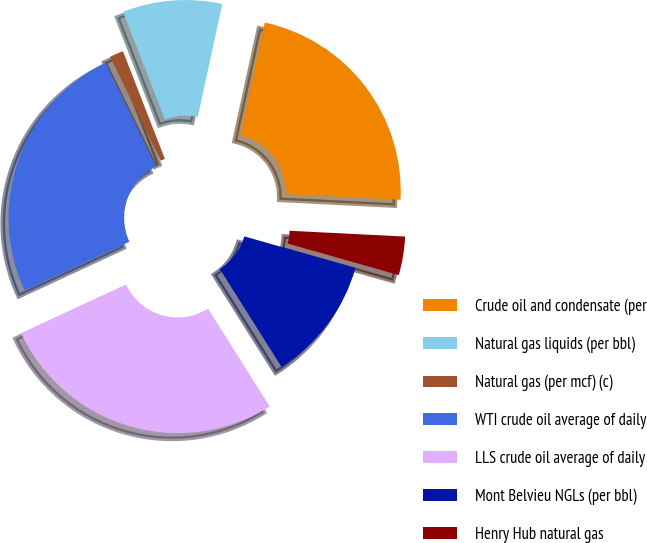<chart> <loc_0><loc_0><loc_500><loc_500><pie_chart><fcel>Crude oil and condensate (per<fcel>Natural gas liquids (per bbl)<fcel>Natural gas (per mcf) (c)<fcel>WTI crude oil average of daily<fcel>LLS crude oil average of daily<fcel>Mont Belvieu NGLs (per bbl)<fcel>Henry Hub natural gas<nl><fcel>22.39%<fcel>9.32%<fcel>1.29%<fcel>24.71%<fcel>27.03%<fcel>11.65%<fcel>3.61%<nl></chart> 